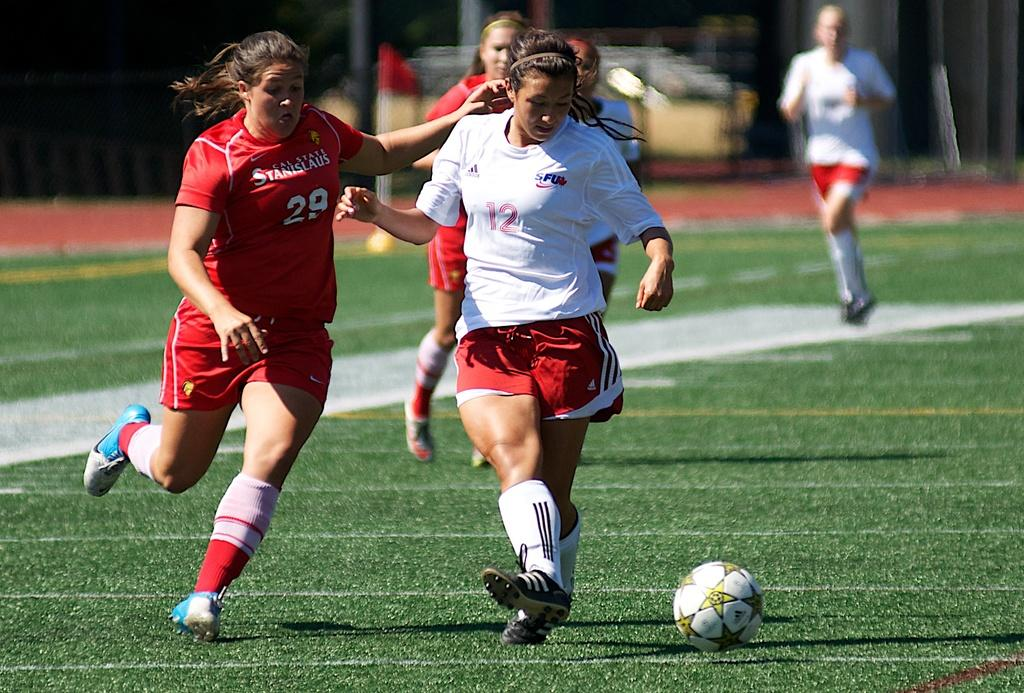<image>
Provide a brief description of the given image. A girl playing soccer wearing the number 12 running with the ball. 